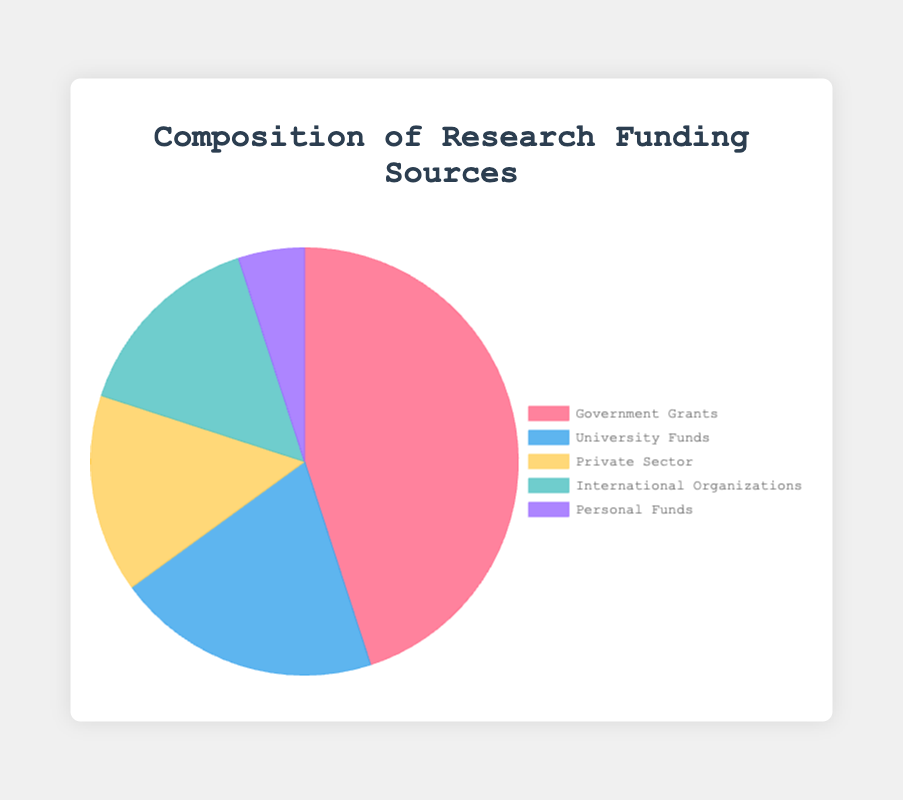How much more funding is received from Government Grants compared to Private Sector? Subtract the percentage of funding from Private Sector (15%) from the percentage of funding from Government Grants (45%). 45% - 15% = 30%
Answer: 30% What is the total percentage of funding from Private Sector and International Organizations combined? Sum the percentages of funding from Private Sector (15%) and International Organizations (15%). 15% + 15% = 30%
Answer: 30% Which funding source contributes the smallest percentage to research funding? Among the given sources, Personal Funds contribute the smallest percentage (5%).
Answer: Personal Funds By how much does University Funds' percentage exceed that of Personal Funds? Subtract the percentage of Personal Funds (5%) from the percentage of University Funds (20%). 20% - 5% = 15%
Answer: 15% What is the difference in funding percentage between the highest and lowest contributors? Subtract the percentage of the lowest contributor, Personal Funds (5%), from the highest contributor, Government Grants (45%). 45% - 5% = 40%
Answer: 40% What fraction of the total funding is provided by International Organizations? The percentage provided by International Organizations is 15%. To convert to a fraction, 15% is equivalent to 15/100, which simplifies to 3/20.
Answer: 3/20 Which two funding sources have equal contributions? Both Private Sector and International Organizations contribute 15% each, making their contributions equal.
Answer: Private Sector and International Organizations What is the combined contribution of University Funds and Personal Funds? Sum the percentages of University Funds (20%) and Personal Funds (5%). 20% + 5% = 25%
Answer: 25% Which funding source is depicted with the blue color in the pie chart? Referring to the color allocation specified, University Funds are depicted with the blue color.
Answer: University Funds 